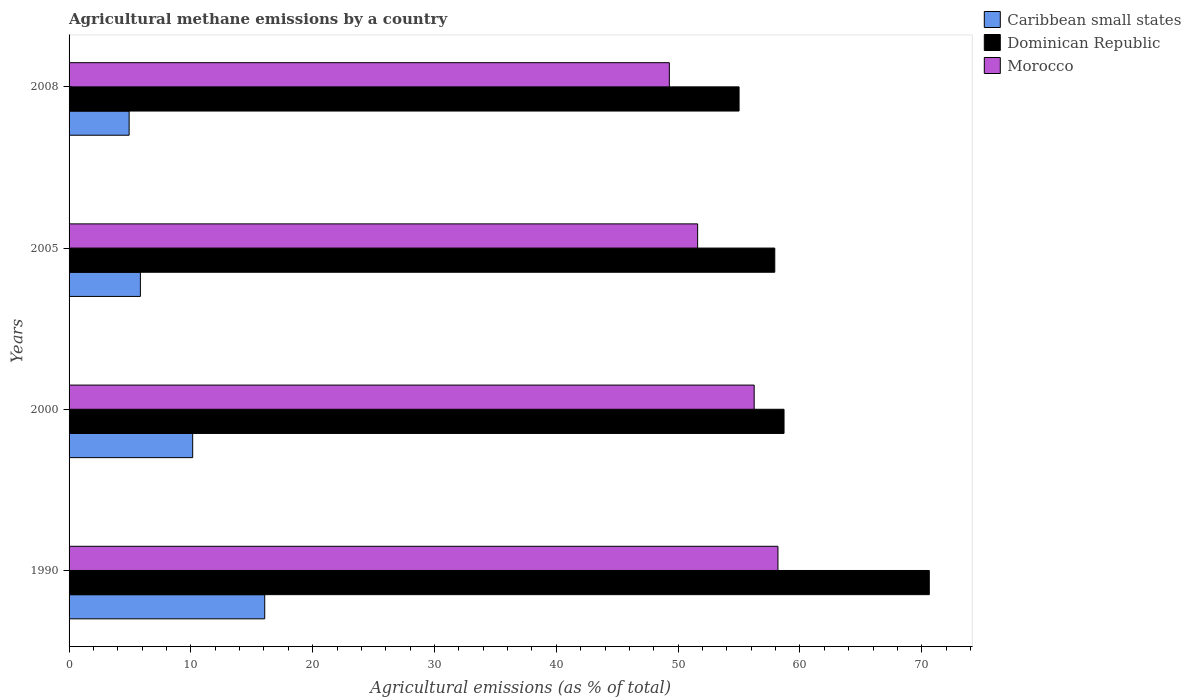How many groups of bars are there?
Give a very brief answer. 4. How many bars are there on the 4th tick from the top?
Provide a short and direct response. 3. How many bars are there on the 1st tick from the bottom?
Make the answer very short. 3. What is the label of the 3rd group of bars from the top?
Provide a short and direct response. 2000. What is the amount of agricultural methane emitted in Morocco in 2008?
Your answer should be compact. 49.28. Across all years, what is the maximum amount of agricultural methane emitted in Caribbean small states?
Keep it short and to the point. 16.06. Across all years, what is the minimum amount of agricultural methane emitted in Caribbean small states?
Your answer should be very brief. 4.93. What is the total amount of agricultural methane emitted in Morocco in the graph?
Your answer should be very brief. 215.32. What is the difference between the amount of agricultural methane emitted in Dominican Republic in 1990 and that in 2005?
Your answer should be very brief. 12.68. What is the difference between the amount of agricultural methane emitted in Dominican Republic in 2005 and the amount of agricultural methane emitted in Morocco in 2000?
Keep it short and to the point. 1.69. What is the average amount of agricultural methane emitted in Morocco per year?
Your response must be concise. 53.83. In the year 1990, what is the difference between the amount of agricultural methane emitted in Caribbean small states and amount of agricultural methane emitted in Morocco?
Make the answer very short. -42.13. What is the ratio of the amount of agricultural methane emitted in Morocco in 1990 to that in 2005?
Your response must be concise. 1.13. What is the difference between the highest and the second highest amount of agricultural methane emitted in Morocco?
Your answer should be very brief. 1.95. What is the difference between the highest and the lowest amount of agricultural methane emitted in Dominican Republic?
Keep it short and to the point. 15.61. In how many years, is the amount of agricultural methane emitted in Caribbean small states greater than the average amount of agricultural methane emitted in Caribbean small states taken over all years?
Provide a short and direct response. 2. Is the sum of the amount of agricultural methane emitted in Dominican Republic in 1990 and 2000 greater than the maximum amount of agricultural methane emitted in Caribbean small states across all years?
Offer a terse response. Yes. What does the 2nd bar from the top in 2000 represents?
Your answer should be compact. Dominican Republic. What does the 3rd bar from the bottom in 2000 represents?
Your answer should be very brief. Morocco. Is it the case that in every year, the sum of the amount of agricultural methane emitted in Dominican Republic and amount of agricultural methane emitted in Caribbean small states is greater than the amount of agricultural methane emitted in Morocco?
Keep it short and to the point. Yes. What is the difference between two consecutive major ticks on the X-axis?
Offer a terse response. 10. Does the graph contain any zero values?
Offer a very short reply. No. How are the legend labels stacked?
Give a very brief answer. Vertical. What is the title of the graph?
Provide a succinct answer. Agricultural methane emissions by a country. Does "Sri Lanka" appear as one of the legend labels in the graph?
Your answer should be compact. No. What is the label or title of the X-axis?
Give a very brief answer. Agricultural emissions (as % of total). What is the label or title of the Y-axis?
Your answer should be compact. Years. What is the Agricultural emissions (as % of total) of Caribbean small states in 1990?
Keep it short and to the point. 16.06. What is the Agricultural emissions (as % of total) of Dominican Republic in 1990?
Give a very brief answer. 70.62. What is the Agricultural emissions (as % of total) of Morocco in 1990?
Your response must be concise. 58.2. What is the Agricultural emissions (as % of total) in Caribbean small states in 2000?
Offer a terse response. 10.15. What is the Agricultural emissions (as % of total) of Dominican Republic in 2000?
Provide a short and direct response. 58.69. What is the Agricultural emissions (as % of total) of Morocco in 2000?
Offer a terse response. 56.24. What is the Agricultural emissions (as % of total) in Caribbean small states in 2005?
Ensure brevity in your answer.  5.85. What is the Agricultural emissions (as % of total) of Dominican Republic in 2005?
Your answer should be very brief. 57.94. What is the Agricultural emissions (as % of total) of Morocco in 2005?
Offer a very short reply. 51.6. What is the Agricultural emissions (as % of total) in Caribbean small states in 2008?
Provide a short and direct response. 4.93. What is the Agricultural emissions (as % of total) of Dominican Republic in 2008?
Make the answer very short. 55. What is the Agricultural emissions (as % of total) of Morocco in 2008?
Offer a terse response. 49.28. Across all years, what is the maximum Agricultural emissions (as % of total) in Caribbean small states?
Keep it short and to the point. 16.06. Across all years, what is the maximum Agricultural emissions (as % of total) of Dominican Republic?
Your answer should be very brief. 70.62. Across all years, what is the maximum Agricultural emissions (as % of total) of Morocco?
Ensure brevity in your answer.  58.2. Across all years, what is the minimum Agricultural emissions (as % of total) of Caribbean small states?
Ensure brevity in your answer.  4.93. Across all years, what is the minimum Agricultural emissions (as % of total) in Dominican Republic?
Your answer should be very brief. 55. Across all years, what is the minimum Agricultural emissions (as % of total) of Morocco?
Offer a terse response. 49.28. What is the total Agricultural emissions (as % of total) in Caribbean small states in the graph?
Your answer should be compact. 37. What is the total Agricultural emissions (as % of total) in Dominican Republic in the graph?
Give a very brief answer. 242.25. What is the total Agricultural emissions (as % of total) of Morocco in the graph?
Your answer should be very brief. 215.32. What is the difference between the Agricultural emissions (as % of total) in Caribbean small states in 1990 and that in 2000?
Make the answer very short. 5.91. What is the difference between the Agricultural emissions (as % of total) in Dominican Republic in 1990 and that in 2000?
Make the answer very short. 11.92. What is the difference between the Agricultural emissions (as % of total) in Morocco in 1990 and that in 2000?
Your answer should be compact. 1.95. What is the difference between the Agricultural emissions (as % of total) of Caribbean small states in 1990 and that in 2005?
Provide a short and direct response. 10.21. What is the difference between the Agricultural emissions (as % of total) of Dominican Republic in 1990 and that in 2005?
Your answer should be compact. 12.68. What is the difference between the Agricultural emissions (as % of total) in Morocco in 1990 and that in 2005?
Your response must be concise. 6.59. What is the difference between the Agricultural emissions (as % of total) of Caribbean small states in 1990 and that in 2008?
Make the answer very short. 11.13. What is the difference between the Agricultural emissions (as % of total) of Dominican Republic in 1990 and that in 2008?
Your response must be concise. 15.61. What is the difference between the Agricultural emissions (as % of total) of Morocco in 1990 and that in 2008?
Provide a succinct answer. 8.92. What is the difference between the Agricultural emissions (as % of total) of Caribbean small states in 2000 and that in 2005?
Your answer should be compact. 4.29. What is the difference between the Agricultural emissions (as % of total) of Dominican Republic in 2000 and that in 2005?
Your answer should be compact. 0.76. What is the difference between the Agricultural emissions (as % of total) in Morocco in 2000 and that in 2005?
Your response must be concise. 4.64. What is the difference between the Agricultural emissions (as % of total) of Caribbean small states in 2000 and that in 2008?
Your response must be concise. 5.22. What is the difference between the Agricultural emissions (as % of total) of Dominican Republic in 2000 and that in 2008?
Offer a very short reply. 3.69. What is the difference between the Agricultural emissions (as % of total) in Morocco in 2000 and that in 2008?
Offer a very short reply. 6.97. What is the difference between the Agricultural emissions (as % of total) in Caribbean small states in 2005 and that in 2008?
Provide a short and direct response. 0.92. What is the difference between the Agricultural emissions (as % of total) in Dominican Republic in 2005 and that in 2008?
Your answer should be compact. 2.93. What is the difference between the Agricultural emissions (as % of total) of Morocco in 2005 and that in 2008?
Your answer should be compact. 2.32. What is the difference between the Agricultural emissions (as % of total) of Caribbean small states in 1990 and the Agricultural emissions (as % of total) of Dominican Republic in 2000?
Offer a terse response. -42.63. What is the difference between the Agricultural emissions (as % of total) of Caribbean small states in 1990 and the Agricultural emissions (as % of total) of Morocco in 2000?
Give a very brief answer. -40.18. What is the difference between the Agricultural emissions (as % of total) in Dominican Republic in 1990 and the Agricultural emissions (as % of total) in Morocco in 2000?
Your response must be concise. 14.37. What is the difference between the Agricultural emissions (as % of total) of Caribbean small states in 1990 and the Agricultural emissions (as % of total) of Dominican Republic in 2005?
Your response must be concise. -41.87. What is the difference between the Agricultural emissions (as % of total) in Caribbean small states in 1990 and the Agricultural emissions (as % of total) in Morocco in 2005?
Offer a terse response. -35.54. What is the difference between the Agricultural emissions (as % of total) of Dominican Republic in 1990 and the Agricultural emissions (as % of total) of Morocco in 2005?
Provide a succinct answer. 19.02. What is the difference between the Agricultural emissions (as % of total) in Caribbean small states in 1990 and the Agricultural emissions (as % of total) in Dominican Republic in 2008?
Ensure brevity in your answer.  -38.94. What is the difference between the Agricultural emissions (as % of total) of Caribbean small states in 1990 and the Agricultural emissions (as % of total) of Morocco in 2008?
Ensure brevity in your answer.  -33.22. What is the difference between the Agricultural emissions (as % of total) of Dominican Republic in 1990 and the Agricultural emissions (as % of total) of Morocco in 2008?
Make the answer very short. 21.34. What is the difference between the Agricultural emissions (as % of total) in Caribbean small states in 2000 and the Agricultural emissions (as % of total) in Dominican Republic in 2005?
Offer a terse response. -47.79. What is the difference between the Agricultural emissions (as % of total) in Caribbean small states in 2000 and the Agricultural emissions (as % of total) in Morocco in 2005?
Offer a very short reply. -41.45. What is the difference between the Agricultural emissions (as % of total) of Dominican Republic in 2000 and the Agricultural emissions (as % of total) of Morocco in 2005?
Offer a terse response. 7.09. What is the difference between the Agricultural emissions (as % of total) in Caribbean small states in 2000 and the Agricultural emissions (as % of total) in Dominican Republic in 2008?
Give a very brief answer. -44.86. What is the difference between the Agricultural emissions (as % of total) in Caribbean small states in 2000 and the Agricultural emissions (as % of total) in Morocco in 2008?
Your answer should be compact. -39.13. What is the difference between the Agricultural emissions (as % of total) of Dominican Republic in 2000 and the Agricultural emissions (as % of total) of Morocco in 2008?
Provide a succinct answer. 9.42. What is the difference between the Agricultural emissions (as % of total) in Caribbean small states in 2005 and the Agricultural emissions (as % of total) in Dominican Republic in 2008?
Make the answer very short. -49.15. What is the difference between the Agricultural emissions (as % of total) in Caribbean small states in 2005 and the Agricultural emissions (as % of total) in Morocco in 2008?
Offer a very short reply. -43.42. What is the difference between the Agricultural emissions (as % of total) of Dominican Republic in 2005 and the Agricultural emissions (as % of total) of Morocco in 2008?
Offer a terse response. 8.66. What is the average Agricultural emissions (as % of total) in Caribbean small states per year?
Keep it short and to the point. 9.25. What is the average Agricultural emissions (as % of total) of Dominican Republic per year?
Give a very brief answer. 60.56. What is the average Agricultural emissions (as % of total) of Morocco per year?
Your answer should be very brief. 53.83. In the year 1990, what is the difference between the Agricultural emissions (as % of total) in Caribbean small states and Agricultural emissions (as % of total) in Dominican Republic?
Give a very brief answer. -54.56. In the year 1990, what is the difference between the Agricultural emissions (as % of total) in Caribbean small states and Agricultural emissions (as % of total) in Morocco?
Keep it short and to the point. -42.13. In the year 1990, what is the difference between the Agricultural emissions (as % of total) in Dominican Republic and Agricultural emissions (as % of total) in Morocco?
Offer a very short reply. 12.42. In the year 2000, what is the difference between the Agricultural emissions (as % of total) in Caribbean small states and Agricultural emissions (as % of total) in Dominican Republic?
Ensure brevity in your answer.  -48.55. In the year 2000, what is the difference between the Agricultural emissions (as % of total) of Caribbean small states and Agricultural emissions (as % of total) of Morocco?
Give a very brief answer. -46.1. In the year 2000, what is the difference between the Agricultural emissions (as % of total) of Dominican Republic and Agricultural emissions (as % of total) of Morocco?
Your answer should be very brief. 2.45. In the year 2005, what is the difference between the Agricultural emissions (as % of total) in Caribbean small states and Agricultural emissions (as % of total) in Dominican Republic?
Provide a succinct answer. -52.08. In the year 2005, what is the difference between the Agricultural emissions (as % of total) in Caribbean small states and Agricultural emissions (as % of total) in Morocco?
Your answer should be very brief. -45.75. In the year 2005, what is the difference between the Agricultural emissions (as % of total) in Dominican Republic and Agricultural emissions (as % of total) in Morocco?
Offer a terse response. 6.33. In the year 2008, what is the difference between the Agricultural emissions (as % of total) of Caribbean small states and Agricultural emissions (as % of total) of Dominican Republic?
Offer a terse response. -50.07. In the year 2008, what is the difference between the Agricultural emissions (as % of total) in Caribbean small states and Agricultural emissions (as % of total) in Morocco?
Provide a short and direct response. -44.35. In the year 2008, what is the difference between the Agricultural emissions (as % of total) of Dominican Republic and Agricultural emissions (as % of total) of Morocco?
Offer a very short reply. 5.73. What is the ratio of the Agricultural emissions (as % of total) in Caribbean small states in 1990 to that in 2000?
Your response must be concise. 1.58. What is the ratio of the Agricultural emissions (as % of total) of Dominican Republic in 1990 to that in 2000?
Make the answer very short. 1.2. What is the ratio of the Agricultural emissions (as % of total) of Morocco in 1990 to that in 2000?
Offer a terse response. 1.03. What is the ratio of the Agricultural emissions (as % of total) in Caribbean small states in 1990 to that in 2005?
Make the answer very short. 2.74. What is the ratio of the Agricultural emissions (as % of total) in Dominican Republic in 1990 to that in 2005?
Keep it short and to the point. 1.22. What is the ratio of the Agricultural emissions (as % of total) of Morocco in 1990 to that in 2005?
Your answer should be very brief. 1.13. What is the ratio of the Agricultural emissions (as % of total) in Caribbean small states in 1990 to that in 2008?
Your response must be concise. 3.26. What is the ratio of the Agricultural emissions (as % of total) in Dominican Republic in 1990 to that in 2008?
Your answer should be very brief. 1.28. What is the ratio of the Agricultural emissions (as % of total) in Morocco in 1990 to that in 2008?
Keep it short and to the point. 1.18. What is the ratio of the Agricultural emissions (as % of total) of Caribbean small states in 2000 to that in 2005?
Your answer should be very brief. 1.73. What is the ratio of the Agricultural emissions (as % of total) of Dominican Republic in 2000 to that in 2005?
Offer a very short reply. 1.01. What is the ratio of the Agricultural emissions (as % of total) of Morocco in 2000 to that in 2005?
Make the answer very short. 1.09. What is the ratio of the Agricultural emissions (as % of total) of Caribbean small states in 2000 to that in 2008?
Ensure brevity in your answer.  2.06. What is the ratio of the Agricultural emissions (as % of total) of Dominican Republic in 2000 to that in 2008?
Offer a terse response. 1.07. What is the ratio of the Agricultural emissions (as % of total) of Morocco in 2000 to that in 2008?
Make the answer very short. 1.14. What is the ratio of the Agricultural emissions (as % of total) of Caribbean small states in 2005 to that in 2008?
Make the answer very short. 1.19. What is the ratio of the Agricultural emissions (as % of total) in Dominican Republic in 2005 to that in 2008?
Give a very brief answer. 1.05. What is the ratio of the Agricultural emissions (as % of total) in Morocco in 2005 to that in 2008?
Provide a short and direct response. 1.05. What is the difference between the highest and the second highest Agricultural emissions (as % of total) of Caribbean small states?
Your response must be concise. 5.91. What is the difference between the highest and the second highest Agricultural emissions (as % of total) in Dominican Republic?
Keep it short and to the point. 11.92. What is the difference between the highest and the second highest Agricultural emissions (as % of total) of Morocco?
Ensure brevity in your answer.  1.95. What is the difference between the highest and the lowest Agricultural emissions (as % of total) in Caribbean small states?
Provide a short and direct response. 11.13. What is the difference between the highest and the lowest Agricultural emissions (as % of total) of Dominican Republic?
Your answer should be very brief. 15.61. What is the difference between the highest and the lowest Agricultural emissions (as % of total) in Morocco?
Offer a terse response. 8.92. 